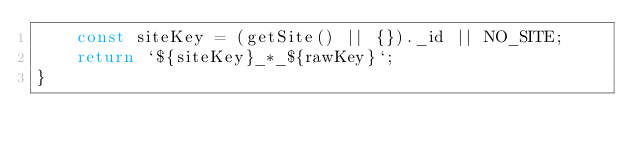Convert code to text. <code><loc_0><loc_0><loc_500><loc_500><_TypeScript_>    const siteKey = (getSite() || {})._id || NO_SITE;
    return `${siteKey}_*_${rawKey}`;
}
</code> 